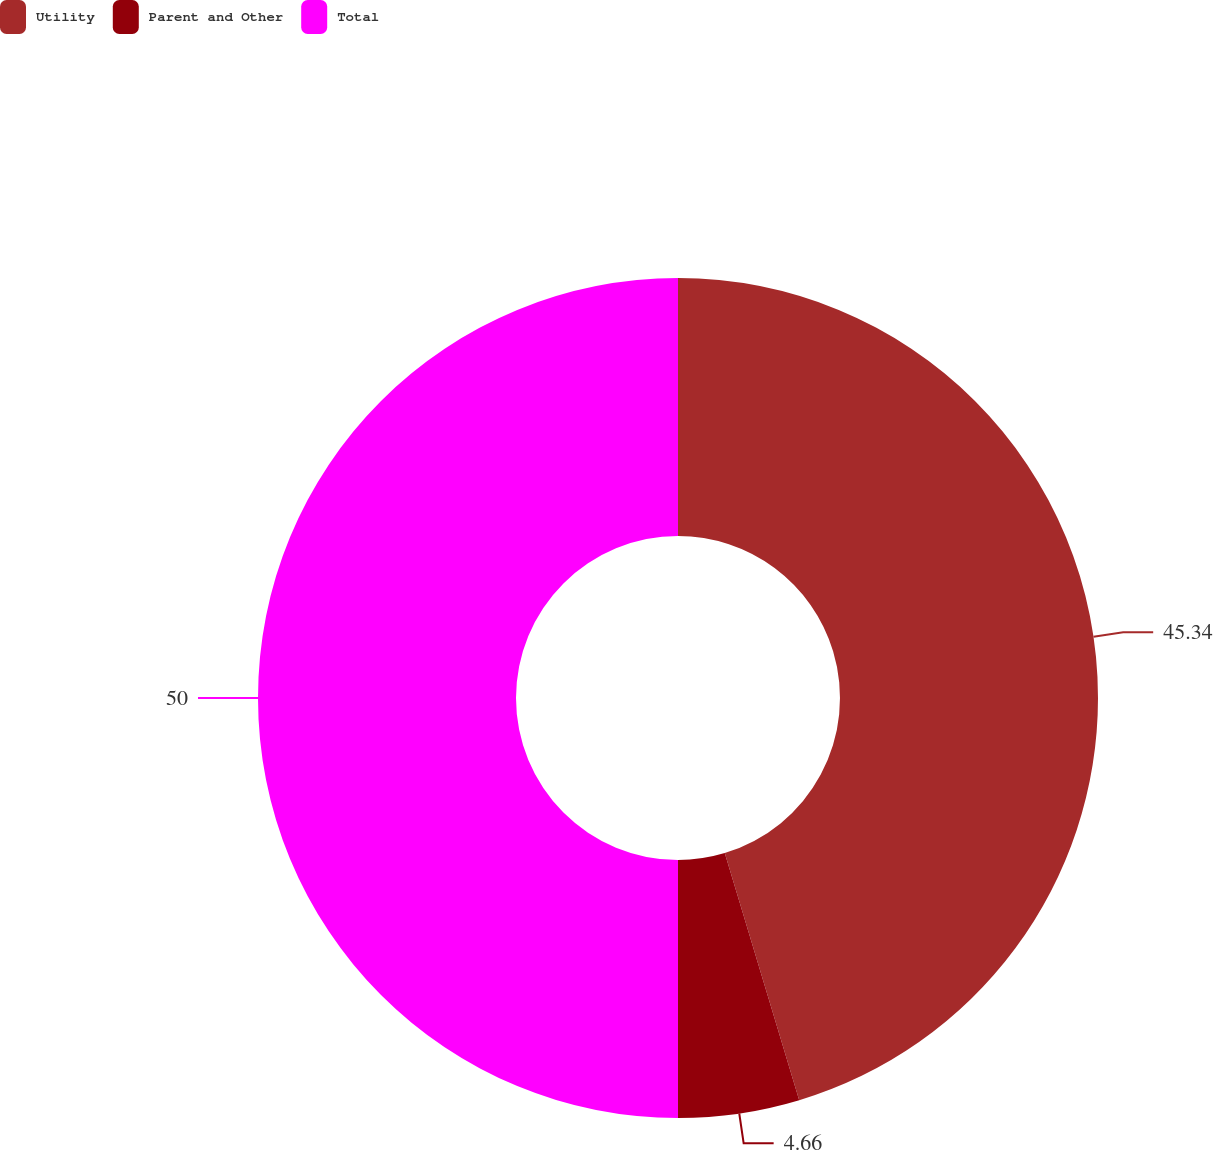Convert chart. <chart><loc_0><loc_0><loc_500><loc_500><pie_chart><fcel>Utility<fcel>Parent and Other<fcel>Total<nl><fcel>45.34%<fcel>4.66%<fcel>50.0%<nl></chart> 